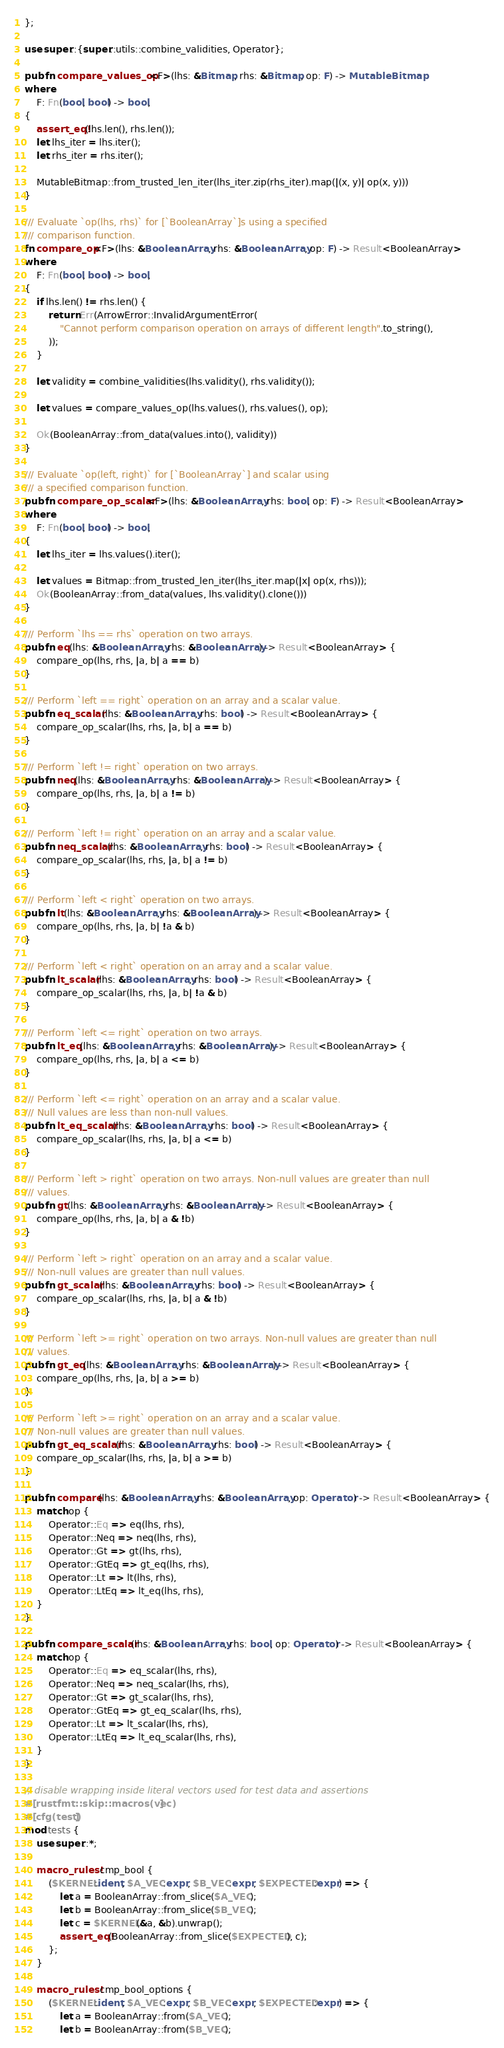<code> <loc_0><loc_0><loc_500><loc_500><_Rust_>};

use super::{super::utils::combine_validities, Operator};

pub fn compare_values_op<F>(lhs: &Bitmap, rhs: &Bitmap, op: F) -> MutableBitmap
where
    F: Fn(bool, bool) -> bool,
{
    assert_eq!(lhs.len(), rhs.len());
    let lhs_iter = lhs.iter();
    let rhs_iter = rhs.iter();

    MutableBitmap::from_trusted_len_iter(lhs_iter.zip(rhs_iter).map(|(x, y)| op(x, y)))
}

/// Evaluate `op(lhs, rhs)` for [`BooleanArray`]s using a specified
/// comparison function.
fn compare_op<F>(lhs: &BooleanArray, rhs: &BooleanArray, op: F) -> Result<BooleanArray>
where
    F: Fn(bool, bool) -> bool,
{
    if lhs.len() != rhs.len() {
        return Err(ArrowError::InvalidArgumentError(
            "Cannot perform comparison operation on arrays of different length".to_string(),
        ));
    }

    let validity = combine_validities(lhs.validity(), rhs.validity());

    let values = compare_values_op(lhs.values(), rhs.values(), op);

    Ok(BooleanArray::from_data(values.into(), validity))
}

/// Evaluate `op(left, right)` for [`BooleanArray`] and scalar using
/// a specified comparison function.
pub fn compare_op_scalar<F>(lhs: &BooleanArray, rhs: bool, op: F) -> Result<BooleanArray>
where
    F: Fn(bool, bool) -> bool,
{
    let lhs_iter = lhs.values().iter();

    let values = Bitmap::from_trusted_len_iter(lhs_iter.map(|x| op(x, rhs)));
    Ok(BooleanArray::from_data(values, lhs.validity().clone()))
}

/// Perform `lhs == rhs` operation on two arrays.
pub fn eq(lhs: &BooleanArray, rhs: &BooleanArray) -> Result<BooleanArray> {
    compare_op(lhs, rhs, |a, b| a == b)
}

/// Perform `left == right` operation on an array and a scalar value.
pub fn eq_scalar(lhs: &BooleanArray, rhs: bool) -> Result<BooleanArray> {
    compare_op_scalar(lhs, rhs, |a, b| a == b)
}

/// Perform `left != right` operation on two arrays.
pub fn neq(lhs: &BooleanArray, rhs: &BooleanArray) -> Result<BooleanArray> {
    compare_op(lhs, rhs, |a, b| a != b)
}

/// Perform `left != right` operation on an array and a scalar value.
pub fn neq_scalar(lhs: &BooleanArray, rhs: bool) -> Result<BooleanArray> {
    compare_op_scalar(lhs, rhs, |a, b| a != b)
}

/// Perform `left < right` operation on two arrays.
pub fn lt(lhs: &BooleanArray, rhs: &BooleanArray) -> Result<BooleanArray> {
    compare_op(lhs, rhs, |a, b| !a & b)
}

/// Perform `left < right` operation on an array and a scalar value.
pub fn lt_scalar(lhs: &BooleanArray, rhs: bool) -> Result<BooleanArray> {
    compare_op_scalar(lhs, rhs, |a, b| !a & b)
}

/// Perform `left <= right` operation on two arrays.
pub fn lt_eq(lhs: &BooleanArray, rhs: &BooleanArray) -> Result<BooleanArray> {
    compare_op(lhs, rhs, |a, b| a <= b)
}

/// Perform `left <= right` operation on an array and a scalar value.
/// Null values are less than non-null values.
pub fn lt_eq_scalar(lhs: &BooleanArray, rhs: bool) -> Result<BooleanArray> {
    compare_op_scalar(lhs, rhs, |a, b| a <= b)
}

/// Perform `left > right` operation on two arrays. Non-null values are greater than null
/// values.
pub fn gt(lhs: &BooleanArray, rhs: &BooleanArray) -> Result<BooleanArray> {
    compare_op(lhs, rhs, |a, b| a & !b)
}

/// Perform `left > right` operation on an array and a scalar value.
/// Non-null values are greater than null values.
pub fn gt_scalar(lhs: &BooleanArray, rhs: bool) -> Result<BooleanArray> {
    compare_op_scalar(lhs, rhs, |a, b| a & !b)
}

/// Perform `left >= right` operation on two arrays. Non-null values are greater than null
/// values.
pub fn gt_eq(lhs: &BooleanArray, rhs: &BooleanArray) -> Result<BooleanArray> {
    compare_op(lhs, rhs, |a, b| a >= b)
}

/// Perform `left >= right` operation on an array and a scalar value.
/// Non-null values are greater than null values.
pub fn gt_eq_scalar(lhs: &BooleanArray, rhs: bool) -> Result<BooleanArray> {
    compare_op_scalar(lhs, rhs, |a, b| a >= b)
}

pub fn compare(lhs: &BooleanArray, rhs: &BooleanArray, op: Operator) -> Result<BooleanArray> {
    match op {
        Operator::Eq => eq(lhs, rhs),
        Operator::Neq => neq(lhs, rhs),
        Operator::Gt => gt(lhs, rhs),
        Operator::GtEq => gt_eq(lhs, rhs),
        Operator::Lt => lt(lhs, rhs),
        Operator::LtEq => lt_eq(lhs, rhs),
    }
}

pub fn compare_scalar(lhs: &BooleanArray, rhs: bool, op: Operator) -> Result<BooleanArray> {
    match op {
        Operator::Eq => eq_scalar(lhs, rhs),
        Operator::Neq => neq_scalar(lhs, rhs),
        Operator::Gt => gt_scalar(lhs, rhs),
        Operator::GtEq => gt_eq_scalar(lhs, rhs),
        Operator::Lt => lt_scalar(lhs, rhs),
        Operator::LtEq => lt_eq_scalar(lhs, rhs),
    }
}

// disable wrapping inside literal vectors used for test data and assertions
#[rustfmt::skip::macros(vec)]
#[cfg(test)]
mod tests {
    use super::*;

    macro_rules! cmp_bool {
        ($KERNEL:ident, $A_VEC:expr, $B_VEC:expr, $EXPECTED:expr) => {
            let a = BooleanArray::from_slice($A_VEC);
            let b = BooleanArray::from_slice($B_VEC);
            let c = $KERNEL(&a, &b).unwrap();
            assert_eq!(BooleanArray::from_slice($EXPECTED), c);
        };
    }

    macro_rules! cmp_bool_options {
        ($KERNEL:ident, $A_VEC:expr, $B_VEC:expr, $EXPECTED:expr) => {
            let a = BooleanArray::from($A_VEC);
            let b = BooleanArray::from($B_VEC);</code> 